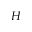<formula> <loc_0><loc_0><loc_500><loc_500>H</formula> 